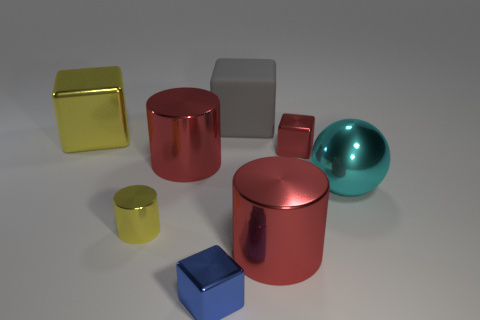Does the tiny yellow cylinder have the same material as the cyan thing?
Keep it short and to the point. Yes. How many small red cubes have the same material as the blue block?
Make the answer very short. 1. There is a ball that is the same material as the red cube; what is its color?
Offer a terse response. Cyan. There is a blue thing; what shape is it?
Your answer should be compact. Cube. There is a cube that is right of the gray block; what is it made of?
Give a very brief answer. Metal. Is there a large shiny thing of the same color as the big rubber cube?
Offer a very short reply. No. What is the shape of the yellow thing that is the same size as the gray rubber thing?
Keep it short and to the point. Cube. The metallic block in front of the small yellow metallic cylinder is what color?
Make the answer very short. Blue. There is a large cylinder in front of the sphere; is there a gray thing that is in front of it?
Provide a short and direct response. No. How many things are either metallic objects left of the large gray object or cyan objects?
Offer a very short reply. 5. 